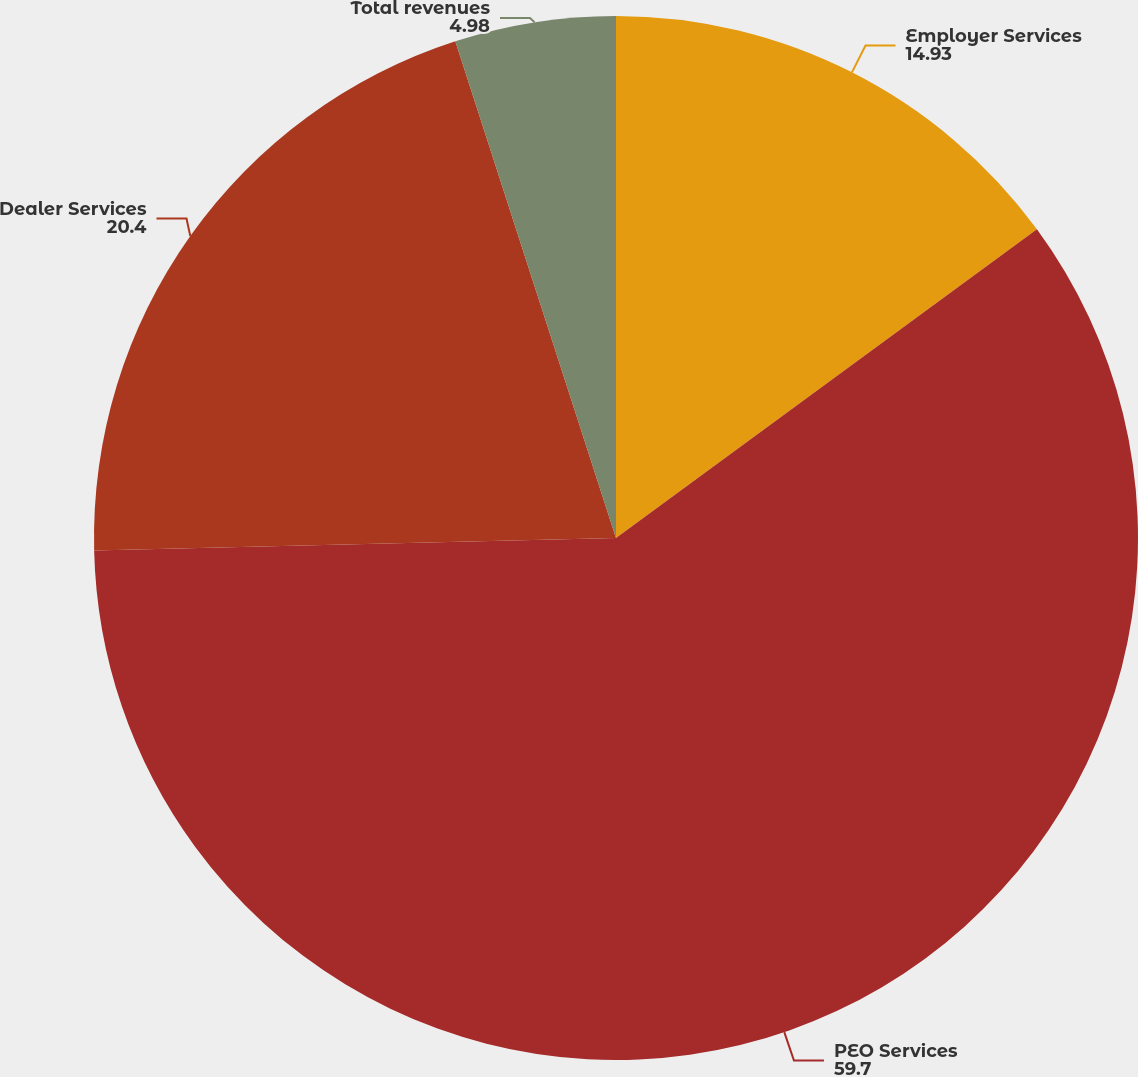Convert chart to OTSL. <chart><loc_0><loc_0><loc_500><loc_500><pie_chart><fcel>Employer Services<fcel>PEO Services<fcel>Dealer Services<fcel>Total revenues<nl><fcel>14.93%<fcel>59.7%<fcel>20.4%<fcel>4.98%<nl></chart> 